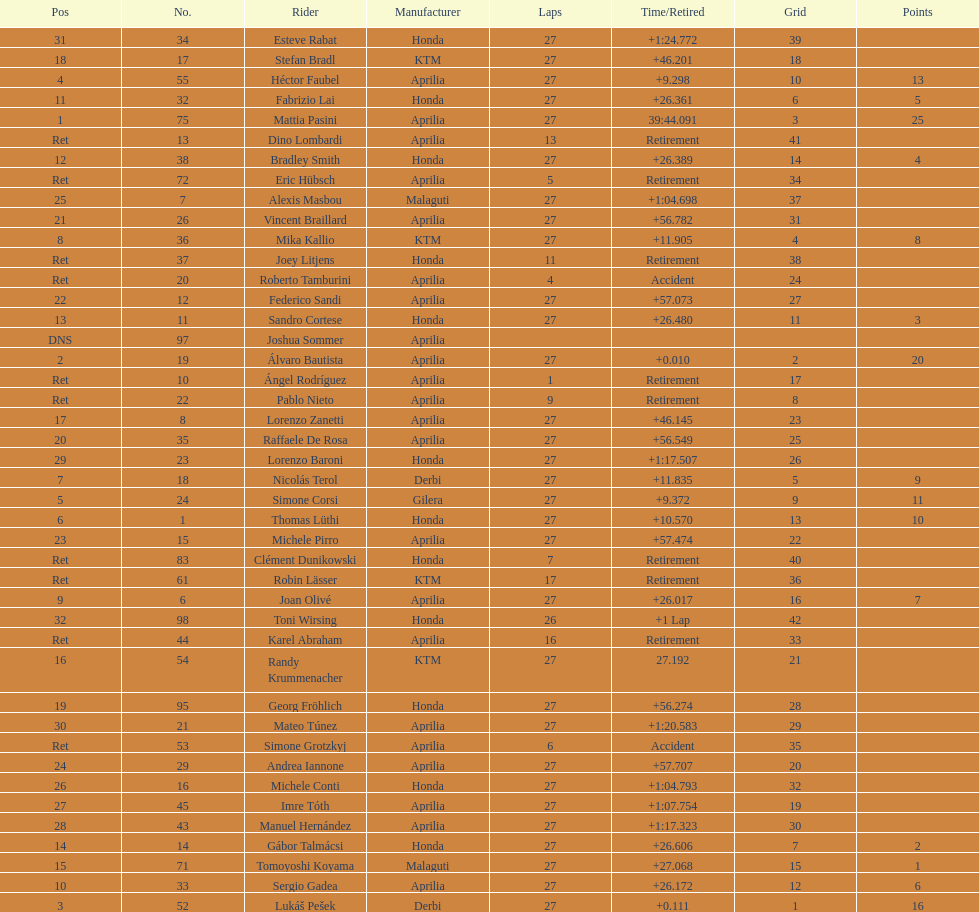Parse the full table. {'header': ['Pos', 'No.', 'Rider', 'Manufacturer', 'Laps', 'Time/Retired', 'Grid', 'Points'], 'rows': [['31', '34', 'Esteve Rabat', 'Honda', '27', '+1:24.772', '39', ''], ['18', '17', 'Stefan Bradl', 'KTM', '27', '+46.201', '18', ''], ['4', '55', 'Héctor Faubel', 'Aprilia', '27', '+9.298', '10', '13'], ['11', '32', 'Fabrizio Lai', 'Honda', '27', '+26.361', '6', '5'], ['1', '75', 'Mattia Pasini', 'Aprilia', '27', '39:44.091', '3', '25'], ['Ret', '13', 'Dino Lombardi', 'Aprilia', '13', 'Retirement', '41', ''], ['12', '38', 'Bradley Smith', 'Honda', '27', '+26.389', '14', '4'], ['Ret', '72', 'Eric Hübsch', 'Aprilia', '5', 'Retirement', '34', ''], ['25', '7', 'Alexis Masbou', 'Malaguti', '27', '+1:04.698', '37', ''], ['21', '26', 'Vincent Braillard', 'Aprilia', '27', '+56.782', '31', ''], ['8', '36', 'Mika Kallio', 'KTM', '27', '+11.905', '4', '8'], ['Ret', '37', 'Joey Litjens', 'Honda', '11', 'Retirement', '38', ''], ['Ret', '20', 'Roberto Tamburini', 'Aprilia', '4', 'Accident', '24', ''], ['22', '12', 'Federico Sandi', 'Aprilia', '27', '+57.073', '27', ''], ['13', '11', 'Sandro Cortese', 'Honda', '27', '+26.480', '11', '3'], ['DNS', '97', 'Joshua Sommer', 'Aprilia', '', '', '', ''], ['2', '19', 'Álvaro Bautista', 'Aprilia', '27', '+0.010', '2', '20'], ['Ret', '10', 'Ángel Rodríguez', 'Aprilia', '1', 'Retirement', '17', ''], ['Ret', '22', 'Pablo Nieto', 'Aprilia', '9', 'Retirement', '8', ''], ['17', '8', 'Lorenzo Zanetti', 'Aprilia', '27', '+46.145', '23', ''], ['20', '35', 'Raffaele De Rosa', 'Aprilia', '27', '+56.549', '25', ''], ['29', '23', 'Lorenzo Baroni', 'Honda', '27', '+1:17.507', '26', ''], ['7', '18', 'Nicolás Terol', 'Derbi', '27', '+11.835', '5', '9'], ['5', '24', 'Simone Corsi', 'Gilera', '27', '+9.372', '9', '11'], ['6', '1', 'Thomas Lüthi', 'Honda', '27', '+10.570', '13', '10'], ['23', '15', 'Michele Pirro', 'Aprilia', '27', '+57.474', '22', ''], ['Ret', '83', 'Clément Dunikowski', 'Honda', '7', 'Retirement', '40', ''], ['Ret', '61', 'Robin Lässer', 'KTM', '17', 'Retirement', '36', ''], ['9', '6', 'Joan Olivé', 'Aprilia', '27', '+26.017', '16', '7'], ['32', '98', 'Toni Wirsing', 'Honda', '26', '+1 Lap', '42', ''], ['Ret', '44', 'Karel Abraham', 'Aprilia', '16', 'Retirement', '33', ''], ['16', '54', 'Randy Krummenacher', 'KTM', '27', '27.192', '21', ''], ['19', '95', 'Georg Fröhlich', 'Honda', '27', '+56.274', '28', ''], ['30', '21', 'Mateo Túnez', 'Aprilia', '27', '+1:20.583', '29', ''], ['Ret', '53', 'Simone Grotzkyj', 'Aprilia', '6', 'Accident', '35', ''], ['24', '29', 'Andrea Iannone', 'Aprilia', '27', '+57.707', '20', ''], ['26', '16', 'Michele Conti', 'Honda', '27', '+1:04.793', '32', ''], ['27', '45', 'Imre Tóth', 'Aprilia', '27', '+1:07.754', '19', ''], ['28', '43', 'Manuel Hernández', 'Aprilia', '27', '+1:17.323', '30', ''], ['14', '14', 'Gábor Talmácsi', 'Honda', '27', '+26.606', '7', '2'], ['15', '71', 'Tomoyoshi Koyama', 'Malaguti', '27', '+27.068', '15', '1'], ['10', '33', 'Sergio Gadea', 'Aprilia', '27', '+26.172', '12', '6'], ['3', '52', 'Lukáš Pešek', 'Derbi', '27', '+0.111', '1', '16']]} Out of everyone with points, who has the smallest number? Tomoyoshi Koyama. 